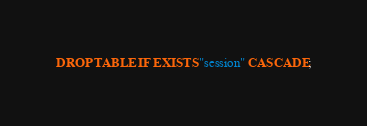<code> <loc_0><loc_0><loc_500><loc_500><_SQL_>DROP TABLE IF EXISTS "session" CASCADE;
</code> 